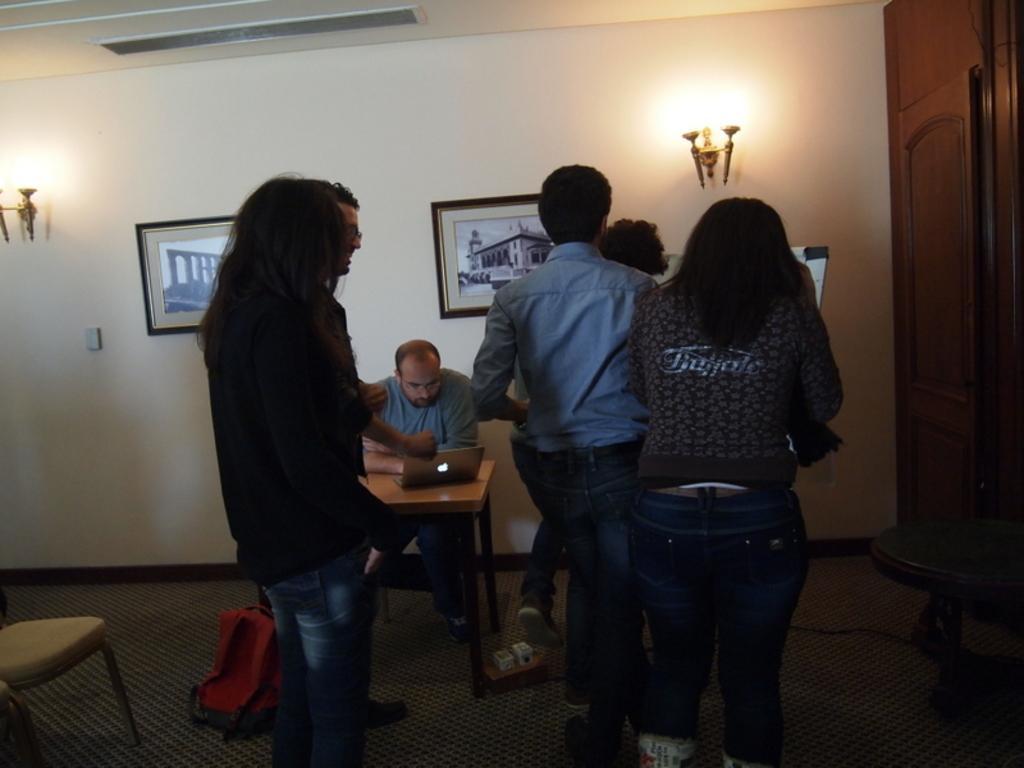Please provide a concise description of this image. In this image I can see few people where one is sitting and rest all are standing. I can also see a laptop and few frames, few lights on this wall. Here I can see a chair and a red bag. 